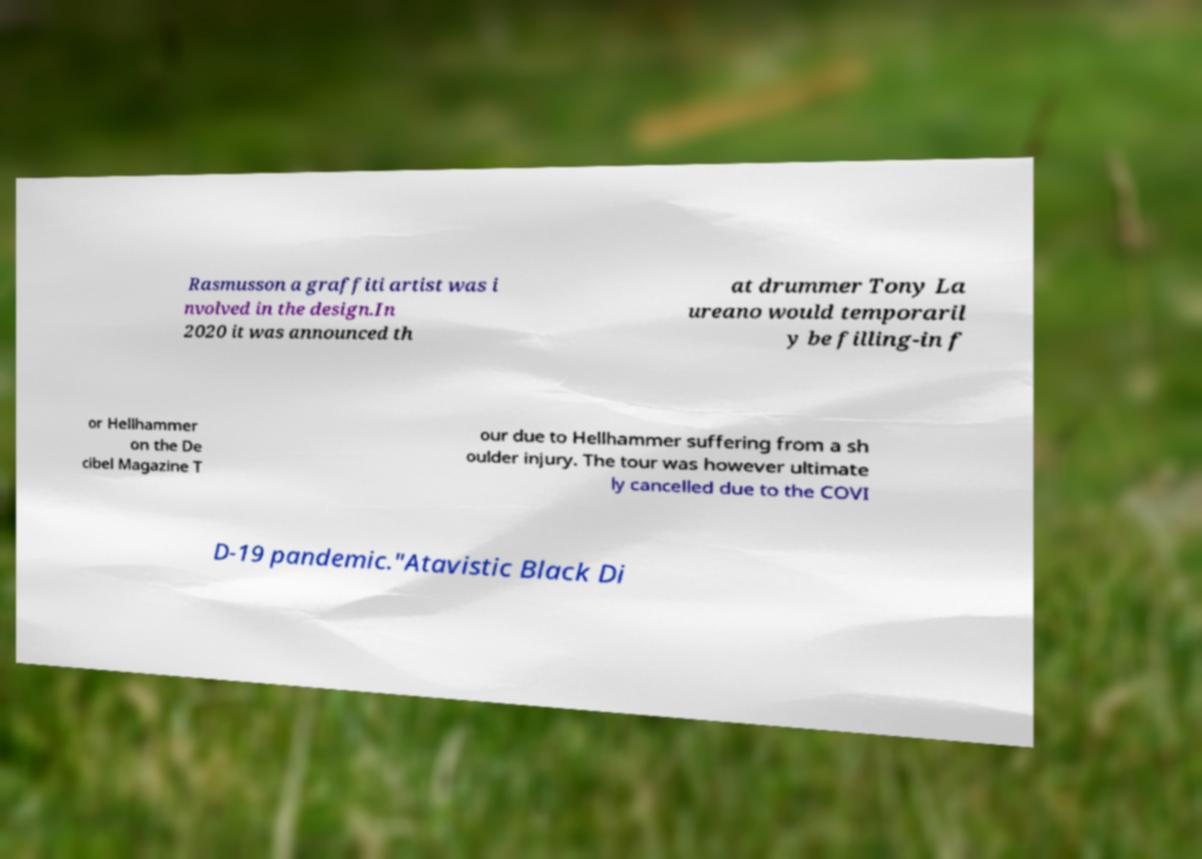Can you read and provide the text displayed in the image?This photo seems to have some interesting text. Can you extract and type it out for me? Rasmusson a graffiti artist was i nvolved in the design.In 2020 it was announced th at drummer Tony La ureano would temporaril y be filling-in f or Hellhammer on the De cibel Magazine T our due to Hellhammer suffering from a sh oulder injury. The tour was however ultimate ly cancelled due to the COVI D-19 pandemic."Atavistic Black Di 